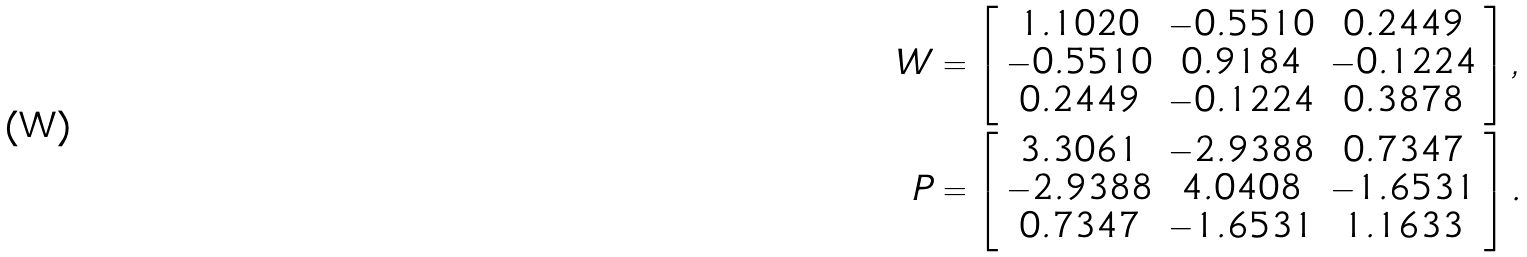<formula> <loc_0><loc_0><loc_500><loc_500>W & = \left [ \begin{array} { c c c } 1 . 1 0 2 0 & - 0 . 5 5 1 0 & 0 . 2 4 4 9 \\ - 0 . 5 5 1 0 & 0 . 9 1 8 4 & - 0 . 1 2 2 4 \\ 0 . 2 4 4 9 & - 0 . 1 2 2 4 & 0 . 3 8 7 8 \\ \end{array} \right ] , \\ P & = \left [ \begin{array} { c c c } 3 . 3 0 6 1 & - 2 . 9 3 8 8 & 0 . 7 3 4 7 \\ - 2 . 9 3 8 8 & 4 . 0 4 0 8 & - 1 . 6 5 3 1 \\ 0 . 7 3 4 7 & - 1 . 6 5 3 1 & 1 . 1 6 3 3 \\ \end{array} \right ] .</formula> 